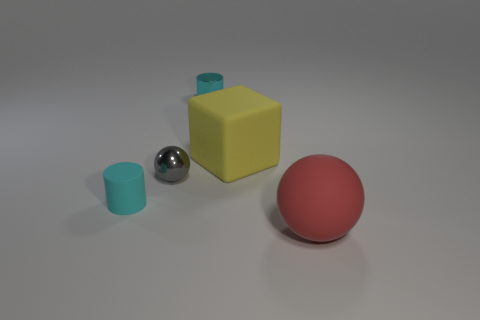How many tiny gray things are the same shape as the big red matte thing?
Your answer should be compact. 1. Do the yellow block and the cyan cylinder that is in front of the gray metal sphere have the same size?
Make the answer very short. No. What is the shape of the cyan thing that is to the left of the cyan object right of the gray metal thing?
Provide a succinct answer. Cylinder. Is the number of yellow matte blocks behind the block less than the number of tiny gray cylinders?
Make the answer very short. No. There is a thing that is the same color as the matte cylinder; what is its shape?
Ensure brevity in your answer.  Cylinder. What number of gray metal things are the same size as the cyan metallic object?
Make the answer very short. 1. What is the shape of the small cyan thing that is behind the small gray sphere?
Make the answer very short. Cylinder. Is the number of yellow objects less than the number of big brown metal things?
Provide a short and direct response. No. Is there any other thing of the same color as the matte ball?
Ensure brevity in your answer.  No. What size is the thing that is left of the tiny shiny sphere?
Give a very brief answer. Small. 